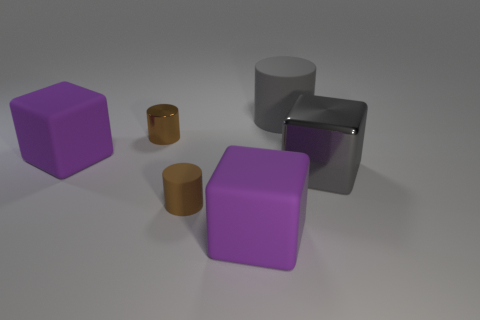Is the number of large purple matte cubes left of the tiny brown rubber thing greater than the number of large gray things that are in front of the large gray block?
Provide a short and direct response. Yes. What material is the other brown cylinder that is the same size as the brown matte cylinder?
Your response must be concise. Metal. What number of other things are made of the same material as the large gray cylinder?
Your answer should be very brief. 3. Do the big thing that is left of the small matte object and the gray object to the right of the big gray matte cylinder have the same shape?
Provide a short and direct response. Yes. How many other objects are there of the same color as the big cylinder?
Your response must be concise. 1. Are the tiny brown thing behind the tiny matte cylinder and the brown cylinder on the right side of the tiny metal object made of the same material?
Keep it short and to the point. No. Is the number of large shiny objects that are left of the tiny metal thing the same as the number of rubber things on the right side of the brown rubber cylinder?
Your answer should be compact. No. There is a big gray object in front of the brown metallic thing; what is its material?
Offer a terse response. Metal. Is the number of large gray cylinders less than the number of tiny gray cubes?
Keep it short and to the point. No. There is a large rubber thing that is in front of the brown metallic cylinder and to the right of the small metallic object; what is its shape?
Provide a succinct answer. Cube. 